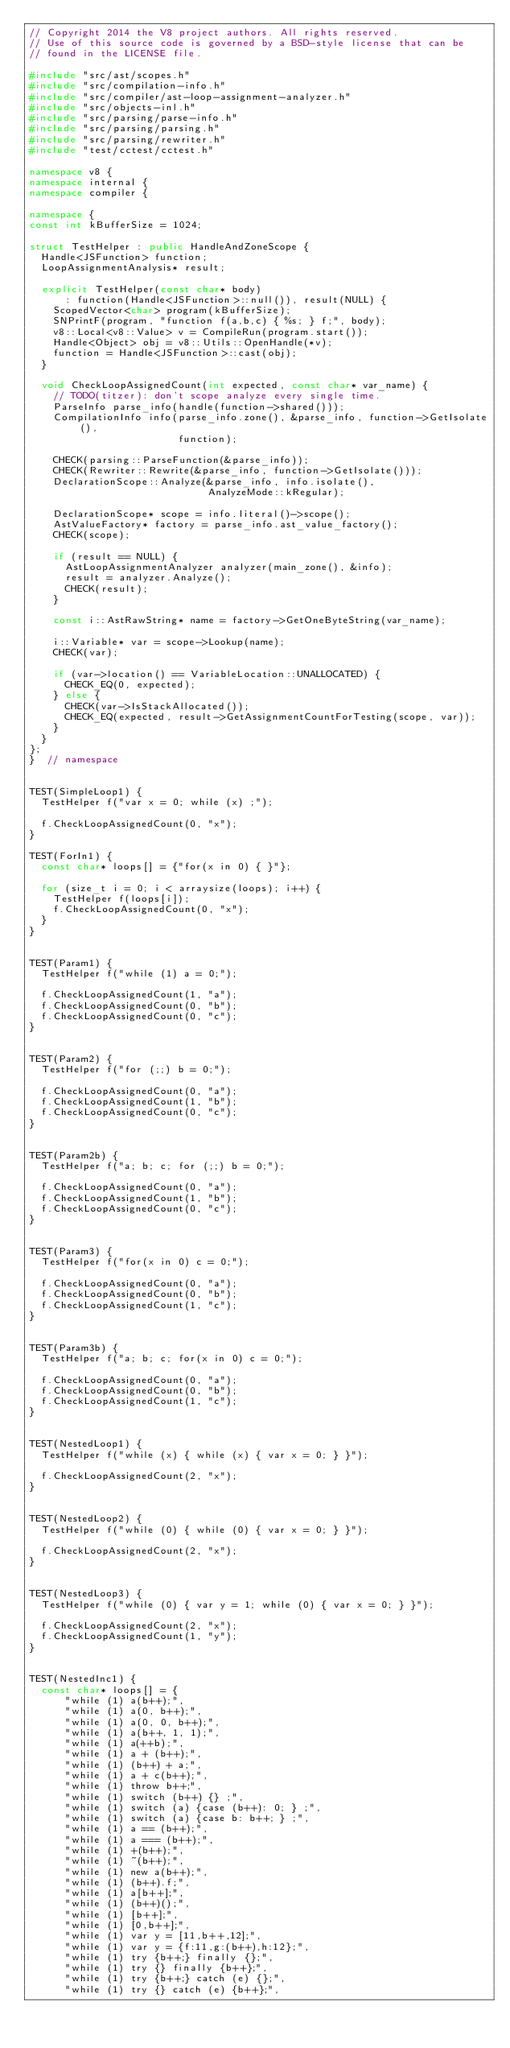<code> <loc_0><loc_0><loc_500><loc_500><_C++_>// Copyright 2014 the V8 project authors. All rights reserved.
// Use of this source code is governed by a BSD-style license that can be
// found in the LICENSE file.

#include "src/ast/scopes.h"
#include "src/compilation-info.h"
#include "src/compiler/ast-loop-assignment-analyzer.h"
#include "src/objects-inl.h"
#include "src/parsing/parse-info.h"
#include "src/parsing/parsing.h"
#include "src/parsing/rewriter.h"
#include "test/cctest/cctest.h"

namespace v8 {
namespace internal {
namespace compiler {

namespace {
const int kBufferSize = 1024;

struct TestHelper : public HandleAndZoneScope {
  Handle<JSFunction> function;
  LoopAssignmentAnalysis* result;

  explicit TestHelper(const char* body)
      : function(Handle<JSFunction>::null()), result(NULL) {
    ScopedVector<char> program(kBufferSize);
    SNPrintF(program, "function f(a,b,c) { %s; } f;", body);
    v8::Local<v8::Value> v = CompileRun(program.start());
    Handle<Object> obj = v8::Utils::OpenHandle(*v);
    function = Handle<JSFunction>::cast(obj);
  }

  void CheckLoopAssignedCount(int expected, const char* var_name) {
    // TODO(titzer): don't scope analyze every single time.
    ParseInfo parse_info(handle(function->shared()));
    CompilationInfo info(parse_info.zone(), &parse_info, function->GetIsolate(),
                         function);

    CHECK(parsing::ParseFunction(&parse_info));
    CHECK(Rewriter::Rewrite(&parse_info, function->GetIsolate()));
    DeclarationScope::Analyze(&parse_info, info.isolate(),
                              AnalyzeMode::kRegular);

    DeclarationScope* scope = info.literal()->scope();
    AstValueFactory* factory = parse_info.ast_value_factory();
    CHECK(scope);

    if (result == NULL) {
      AstLoopAssignmentAnalyzer analyzer(main_zone(), &info);
      result = analyzer.Analyze();
      CHECK(result);
    }

    const i::AstRawString* name = factory->GetOneByteString(var_name);

    i::Variable* var = scope->Lookup(name);
    CHECK(var);

    if (var->location() == VariableLocation::UNALLOCATED) {
      CHECK_EQ(0, expected);
    } else {
      CHECK(var->IsStackAllocated());
      CHECK_EQ(expected, result->GetAssignmentCountForTesting(scope, var));
    }
  }
};
}  // namespace


TEST(SimpleLoop1) {
  TestHelper f("var x = 0; while (x) ;");

  f.CheckLoopAssignedCount(0, "x");
}

TEST(ForIn1) {
  const char* loops[] = {"for(x in 0) { }"};

  for (size_t i = 0; i < arraysize(loops); i++) {
    TestHelper f(loops[i]);
    f.CheckLoopAssignedCount(0, "x");
  }
}


TEST(Param1) {
  TestHelper f("while (1) a = 0;");

  f.CheckLoopAssignedCount(1, "a");
  f.CheckLoopAssignedCount(0, "b");
  f.CheckLoopAssignedCount(0, "c");
}


TEST(Param2) {
  TestHelper f("for (;;) b = 0;");

  f.CheckLoopAssignedCount(0, "a");
  f.CheckLoopAssignedCount(1, "b");
  f.CheckLoopAssignedCount(0, "c");
}


TEST(Param2b) {
  TestHelper f("a; b; c; for (;;) b = 0;");

  f.CheckLoopAssignedCount(0, "a");
  f.CheckLoopAssignedCount(1, "b");
  f.CheckLoopAssignedCount(0, "c");
}


TEST(Param3) {
  TestHelper f("for(x in 0) c = 0;");

  f.CheckLoopAssignedCount(0, "a");
  f.CheckLoopAssignedCount(0, "b");
  f.CheckLoopAssignedCount(1, "c");
}


TEST(Param3b) {
  TestHelper f("a; b; c; for(x in 0) c = 0;");

  f.CheckLoopAssignedCount(0, "a");
  f.CheckLoopAssignedCount(0, "b");
  f.CheckLoopAssignedCount(1, "c");
}


TEST(NestedLoop1) {
  TestHelper f("while (x) { while (x) { var x = 0; } }");

  f.CheckLoopAssignedCount(2, "x");
}


TEST(NestedLoop2) {
  TestHelper f("while (0) { while (0) { var x = 0; } }");

  f.CheckLoopAssignedCount(2, "x");
}


TEST(NestedLoop3) {
  TestHelper f("while (0) { var y = 1; while (0) { var x = 0; } }");

  f.CheckLoopAssignedCount(2, "x");
  f.CheckLoopAssignedCount(1, "y");
}


TEST(NestedInc1) {
  const char* loops[] = {
      "while (1) a(b++);",
      "while (1) a(0, b++);",
      "while (1) a(0, 0, b++);",
      "while (1) a(b++, 1, 1);",
      "while (1) a(++b);",
      "while (1) a + (b++);",
      "while (1) (b++) + a;",
      "while (1) a + c(b++);",
      "while (1) throw b++;",
      "while (1) switch (b++) {} ;",
      "while (1) switch (a) {case (b++): 0; } ;",
      "while (1) switch (a) {case b: b++; } ;",
      "while (1) a == (b++);",
      "while (1) a === (b++);",
      "while (1) +(b++);",
      "while (1) ~(b++);",
      "while (1) new a(b++);",
      "while (1) (b++).f;",
      "while (1) a[b++];",
      "while (1) (b++)();",
      "while (1) [b++];",
      "while (1) [0,b++];",
      "while (1) var y = [11,b++,12];",
      "while (1) var y = {f:11,g:(b++),h:12};",
      "while (1) try {b++;} finally {};",
      "while (1) try {} finally {b++};",
      "while (1) try {b++;} catch (e) {};",
      "while (1) try {} catch (e) {b++};",</code> 